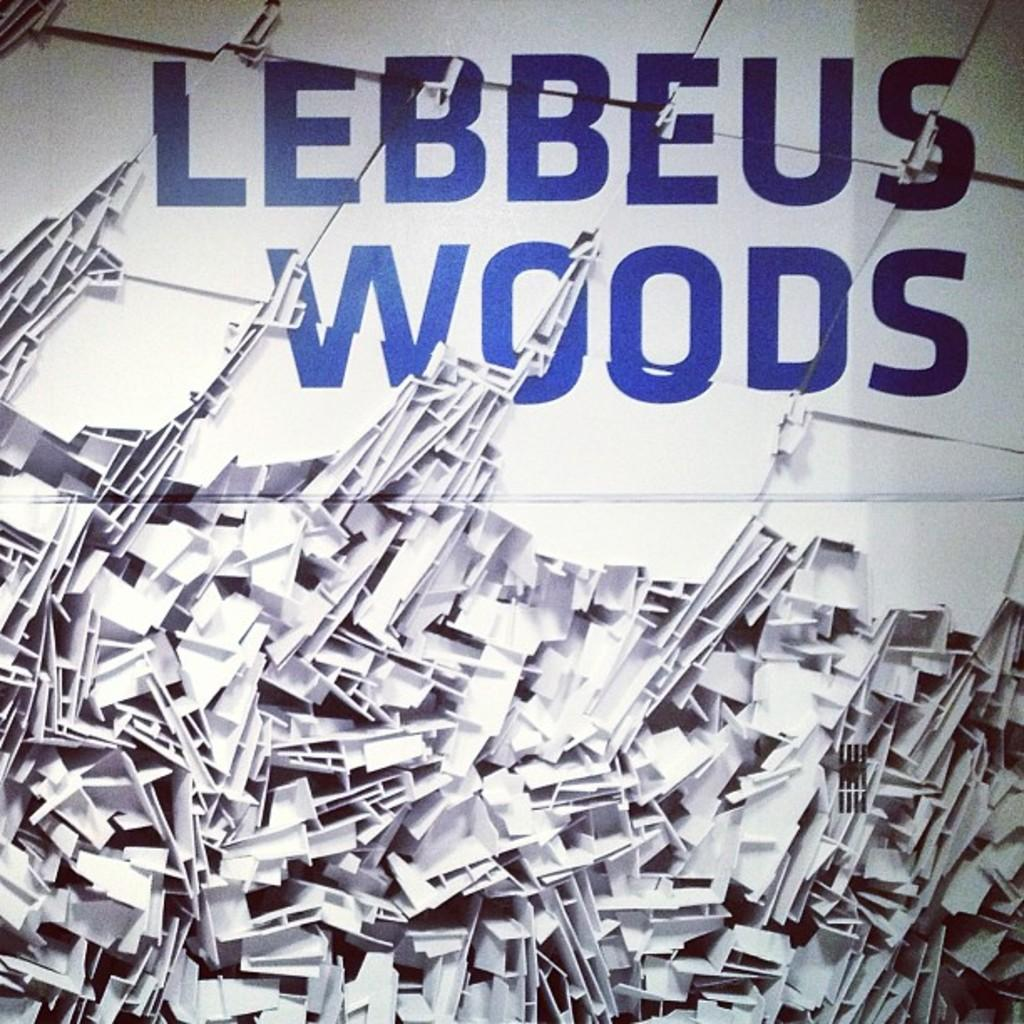<image>
Summarize the visual content of the image. The text "Lebbeus Woods" is written in blue on a white cluttered background. 